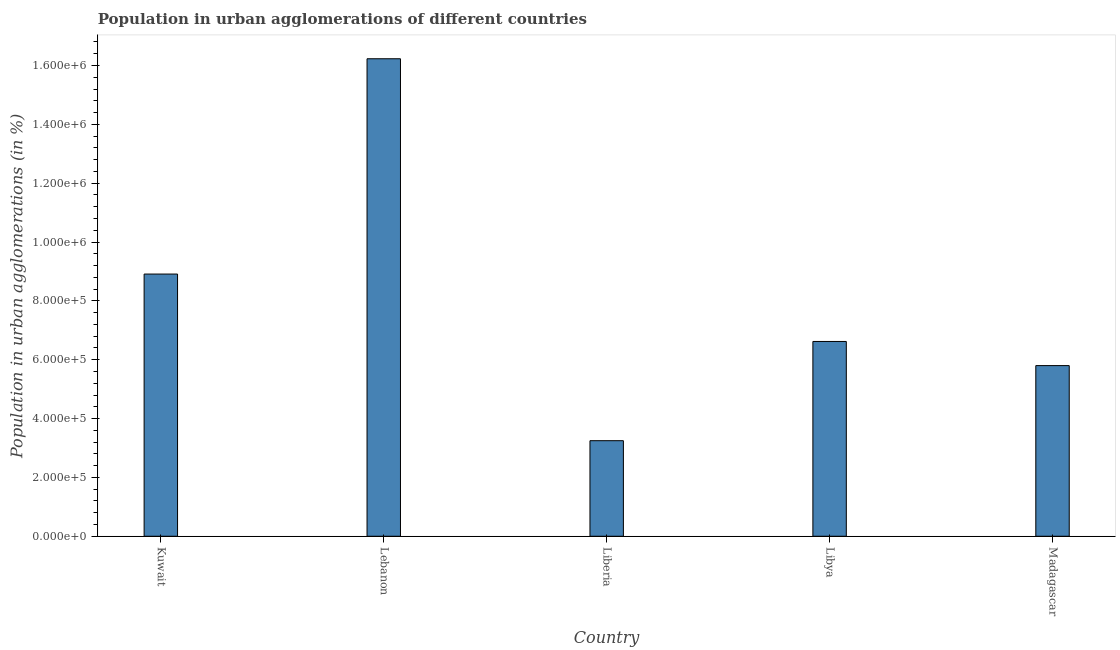Does the graph contain any zero values?
Your answer should be very brief. No. What is the title of the graph?
Make the answer very short. Population in urban agglomerations of different countries. What is the label or title of the X-axis?
Keep it short and to the point. Country. What is the label or title of the Y-axis?
Your answer should be compact. Population in urban agglomerations (in %). What is the population in urban agglomerations in Lebanon?
Your response must be concise. 1.62e+06. Across all countries, what is the maximum population in urban agglomerations?
Offer a terse response. 1.62e+06. Across all countries, what is the minimum population in urban agglomerations?
Offer a very short reply. 3.25e+05. In which country was the population in urban agglomerations maximum?
Offer a terse response. Lebanon. In which country was the population in urban agglomerations minimum?
Provide a short and direct response. Liberia. What is the sum of the population in urban agglomerations?
Offer a terse response. 4.08e+06. What is the difference between the population in urban agglomerations in Kuwait and Lebanon?
Offer a terse response. -7.32e+05. What is the average population in urban agglomerations per country?
Provide a short and direct response. 8.16e+05. What is the median population in urban agglomerations?
Your response must be concise. 6.62e+05. What is the ratio of the population in urban agglomerations in Kuwait to that in Libya?
Offer a very short reply. 1.35. Is the difference between the population in urban agglomerations in Lebanon and Liberia greater than the difference between any two countries?
Offer a terse response. Yes. What is the difference between the highest and the second highest population in urban agglomerations?
Offer a very short reply. 7.32e+05. What is the difference between the highest and the lowest population in urban agglomerations?
Provide a short and direct response. 1.30e+06. How many bars are there?
Make the answer very short. 5. Are all the bars in the graph horizontal?
Provide a succinct answer. No. How many countries are there in the graph?
Your answer should be very brief. 5. What is the difference between two consecutive major ticks on the Y-axis?
Provide a short and direct response. 2.00e+05. What is the Population in urban agglomerations (in %) in Kuwait?
Your answer should be compact. 8.91e+05. What is the Population in urban agglomerations (in %) of Lebanon?
Provide a succinct answer. 1.62e+06. What is the Population in urban agglomerations (in %) in Liberia?
Make the answer very short. 3.25e+05. What is the Population in urban agglomerations (in %) of Libya?
Your response must be concise. 6.62e+05. What is the Population in urban agglomerations (in %) in Madagascar?
Give a very brief answer. 5.80e+05. What is the difference between the Population in urban agglomerations (in %) in Kuwait and Lebanon?
Keep it short and to the point. -7.32e+05. What is the difference between the Population in urban agglomerations (in %) in Kuwait and Liberia?
Offer a very short reply. 5.66e+05. What is the difference between the Population in urban agglomerations (in %) in Kuwait and Libya?
Provide a short and direct response. 2.29e+05. What is the difference between the Population in urban agglomerations (in %) in Kuwait and Madagascar?
Your answer should be compact. 3.11e+05. What is the difference between the Population in urban agglomerations (in %) in Lebanon and Liberia?
Offer a very short reply. 1.30e+06. What is the difference between the Population in urban agglomerations (in %) in Lebanon and Libya?
Keep it short and to the point. 9.61e+05. What is the difference between the Population in urban agglomerations (in %) in Lebanon and Madagascar?
Provide a short and direct response. 1.04e+06. What is the difference between the Population in urban agglomerations (in %) in Liberia and Libya?
Make the answer very short. -3.37e+05. What is the difference between the Population in urban agglomerations (in %) in Liberia and Madagascar?
Offer a terse response. -2.55e+05. What is the difference between the Population in urban agglomerations (in %) in Libya and Madagascar?
Provide a short and direct response. 8.21e+04. What is the ratio of the Population in urban agglomerations (in %) in Kuwait to that in Lebanon?
Your response must be concise. 0.55. What is the ratio of the Population in urban agglomerations (in %) in Kuwait to that in Liberia?
Provide a short and direct response. 2.74. What is the ratio of the Population in urban agglomerations (in %) in Kuwait to that in Libya?
Give a very brief answer. 1.35. What is the ratio of the Population in urban agglomerations (in %) in Kuwait to that in Madagascar?
Make the answer very short. 1.54. What is the ratio of the Population in urban agglomerations (in %) in Lebanon to that in Liberia?
Your answer should be very brief. 5. What is the ratio of the Population in urban agglomerations (in %) in Lebanon to that in Libya?
Offer a terse response. 2.45. What is the ratio of the Population in urban agglomerations (in %) in Lebanon to that in Madagascar?
Provide a succinct answer. 2.8. What is the ratio of the Population in urban agglomerations (in %) in Liberia to that in Libya?
Offer a terse response. 0.49. What is the ratio of the Population in urban agglomerations (in %) in Liberia to that in Madagascar?
Provide a short and direct response. 0.56. What is the ratio of the Population in urban agglomerations (in %) in Libya to that in Madagascar?
Ensure brevity in your answer.  1.14. 